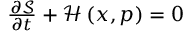Convert formula to latex. <formula><loc_0><loc_0><loc_500><loc_500>\begin{array} { r } { \frac { { \partial \mathcal { S } } } { \partial t } + \mathcal { H } \left ( { x , p } \right ) = 0 } \end{array}</formula> 